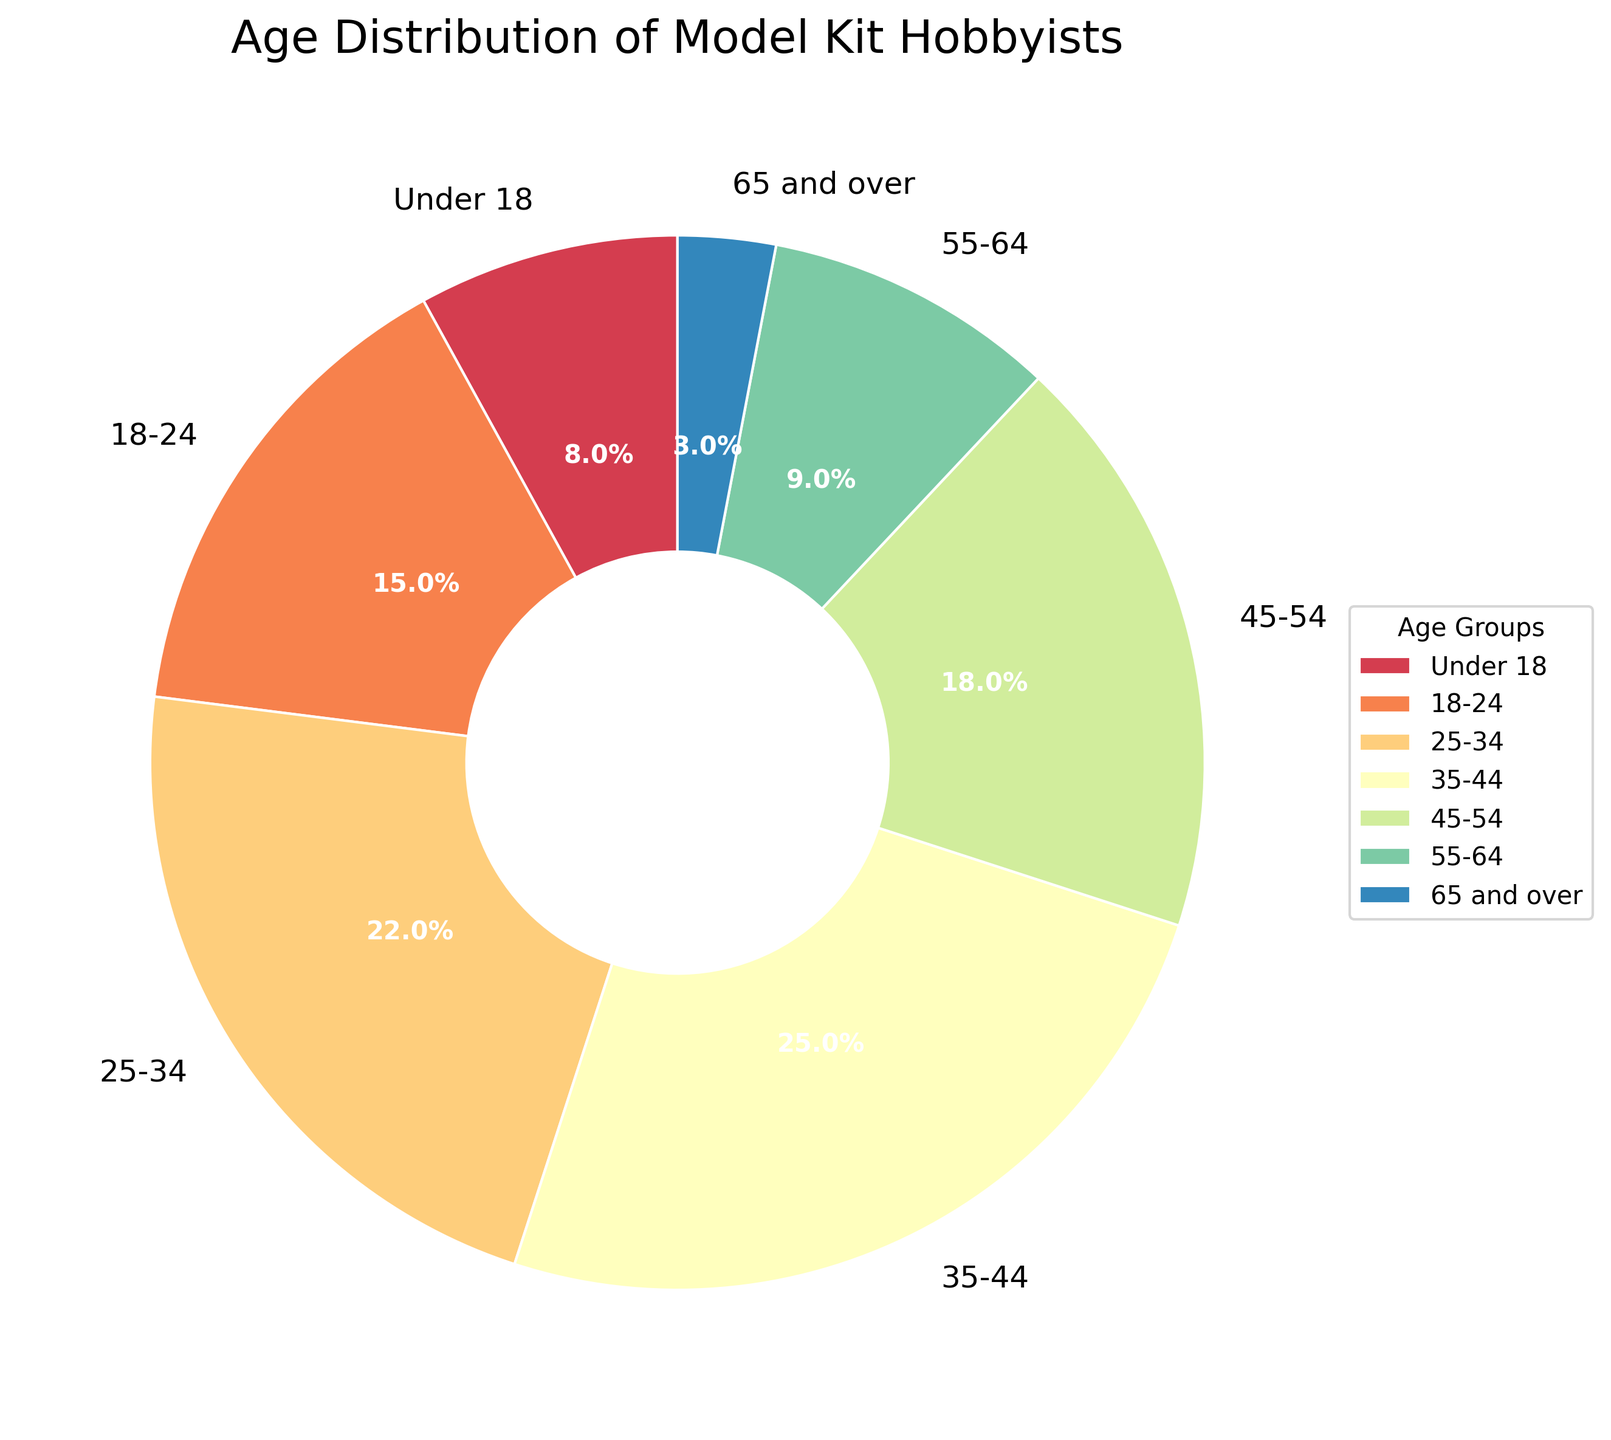What percentage of model kit hobbyists are in the 35-44 age group? The 35-44 age group is directly labeled on the pie chart.
Answer: 25% What is the combined percentage of model kit hobbyists under 18 and those aged 65 and over? Add the percentages for both age groups: 8% (Under 18) + 3% (65 and over) = 11%
Answer: 11% Which age group has the smallest percentage of model kit hobbyists? The percentages for all age groups are labeled on the pie chart. The 65 and over group has the smallest percentage at 3%.
Answer: 65 and over How does the percentage of hobbyists aged 45-54 compare to those aged 55-64? Compare the two percentages directly from the chart: 18% (45-54) and 9% (55-64). The 45-54 age group has a higher percentage.
Answer: 45-54 is higher Which two age groups combined account for approximately half of all model kit hobbyists? Look for two groups whose percentages add up to around 50%. The 25-34 group (22%) and the 35-44 group (25%) combined account for 47%.
Answer: 25-34 and 35-44 What is the total percentage of hobbyists aged 25-44? Add the percentages of the 25-34 and 35-44 age groups: 22% + 25% = 47%
Answer: 47% Which age group represents the second-largest segment of model kit hobbyists? Identify the second-largest percentage after the largest (35-44 at 25%). The second-largest is the 25-34 age group at 22%.
Answer: 25-34 How much larger is the percentage of 35-44 year-olds compared to under 18 year-olds? Subtract the percentage of under 18s from the percentage of 35-44s: 25% - 8% = 17%
Answer: 17% What color represents the 18-24 age group on the pie chart? Identify the color associated with the 18-24 label on the pie chart.
Answer: Depends on the chart What is the percentage difference between the largest and smallest age groups? Subtract the smallest percentage (65 and over at 3%) from the largest (35-44 at 25%): 25% - 3% = 22%
Answer: 22% 